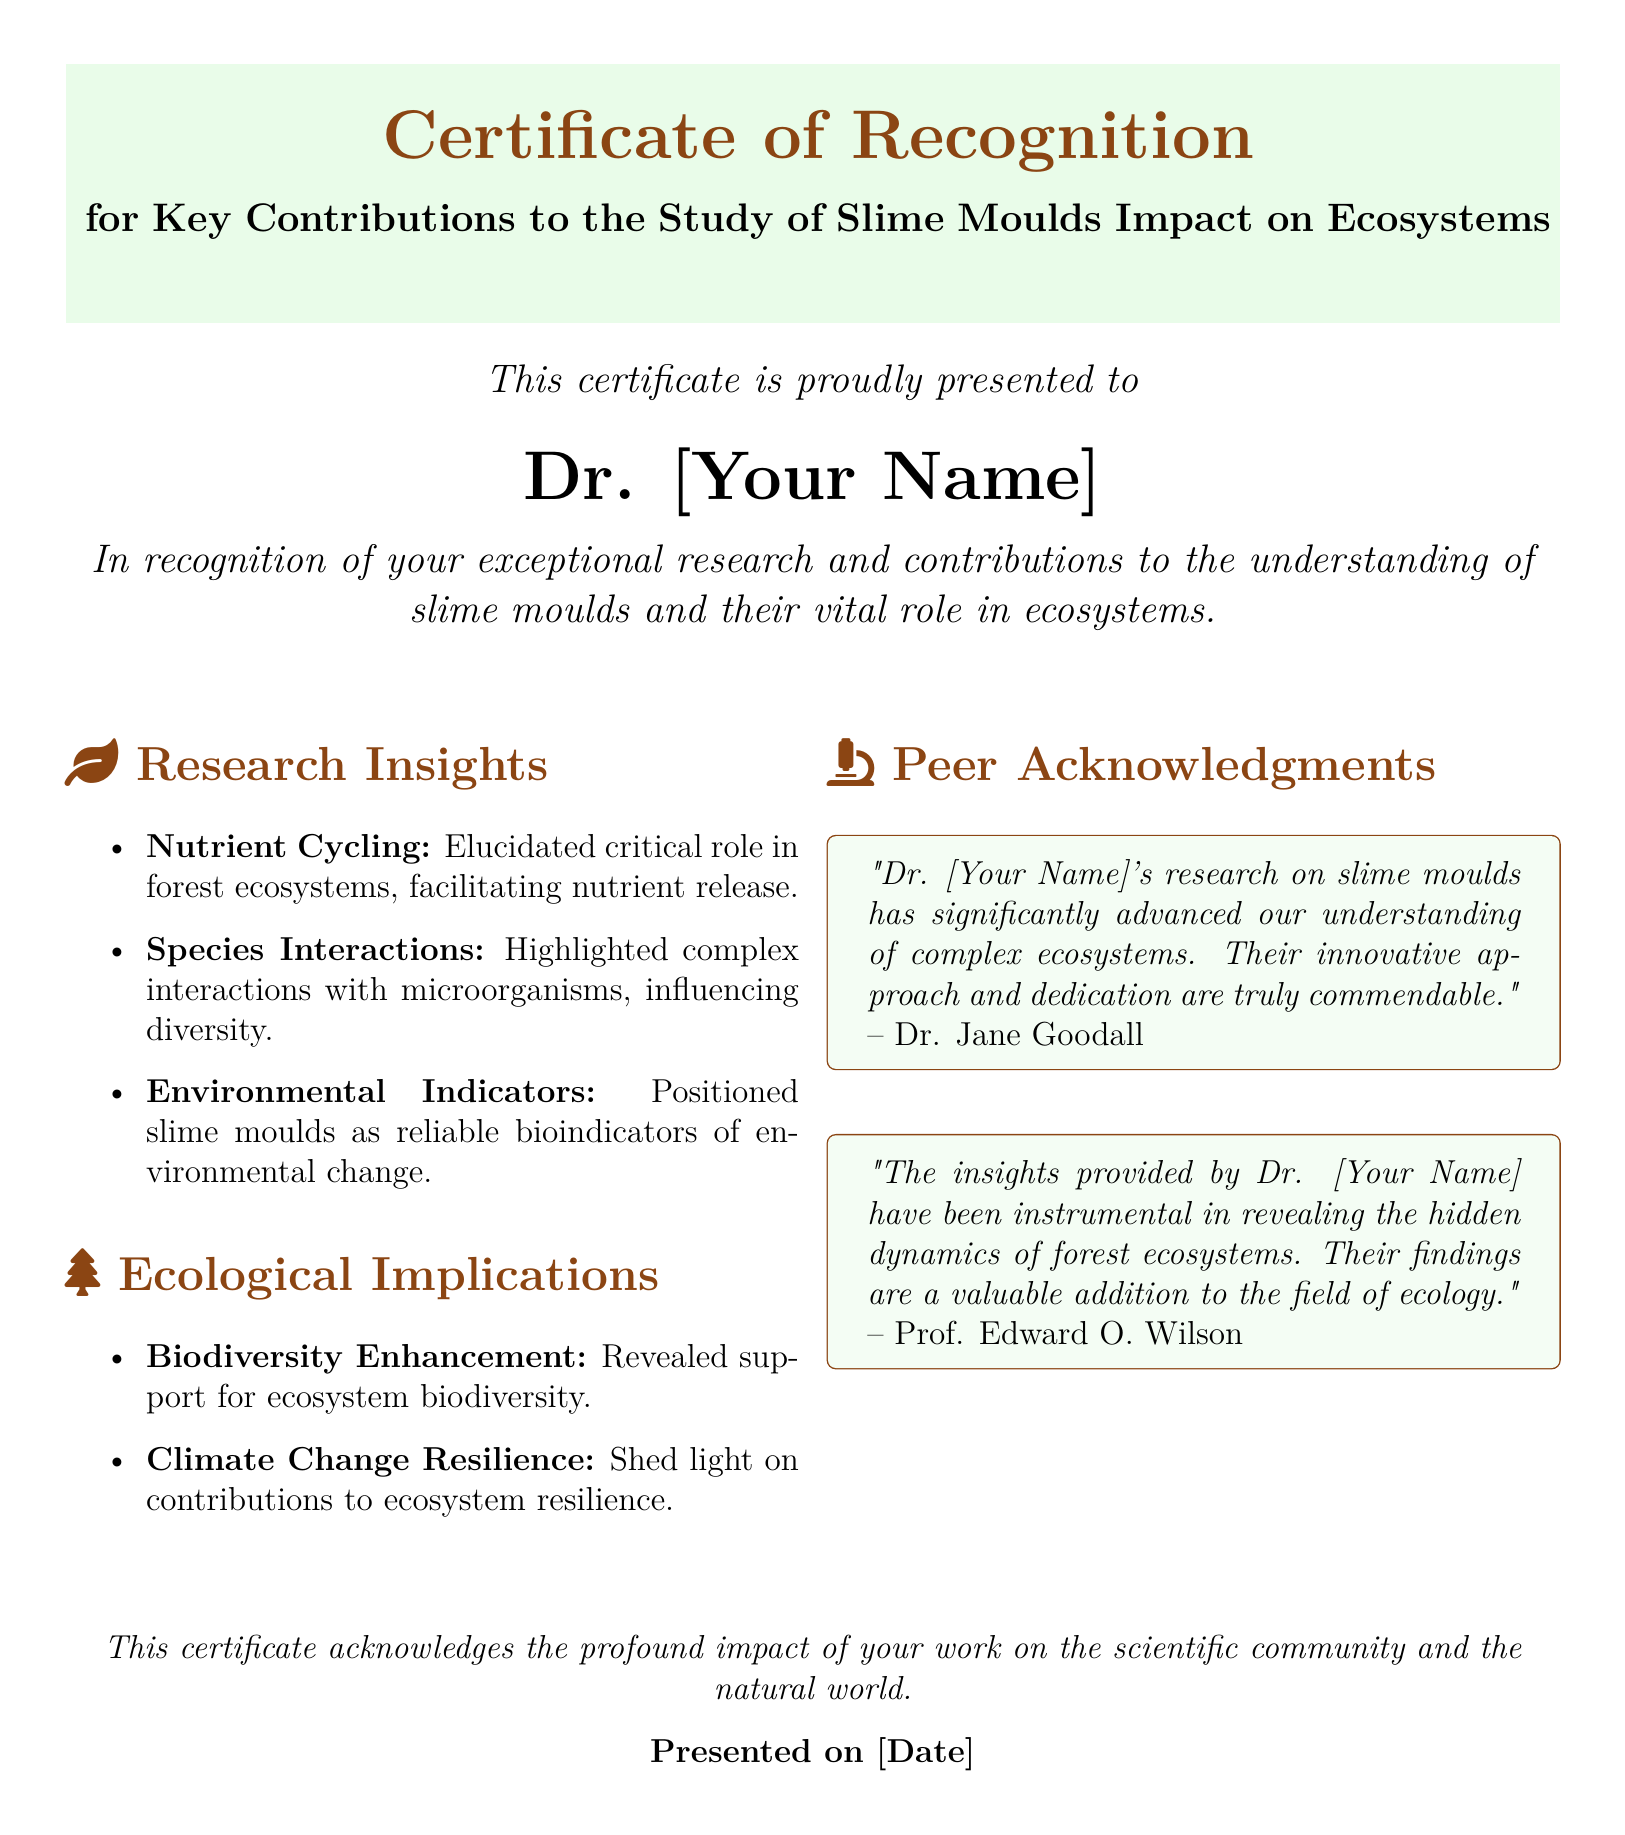What is the title of the certificate? The title of the certificate is presented prominently at the top of the document, highlighting the recognition given.
Answer: Certificate of Recognition for Key Contributions to the Study of Slime Moulds Impact on Ecosystems Who is the certificate presented to? The name of the recipient is clearly stated in the document, acknowledging their contributions.
Answer: Dr. [Your Name] What does the first bullet point under Research Insights mention? The first bullet point specifies a key area of research related to the role of slime moulds in ecosystems.
Answer: Nutrient Cycling What date is this certificate presented on? The presentation date is included at the bottom section of the document.
Answer: [Date] Who acknowledged Dr. [Your Name]'s research stating its significant advancement? A specific acknowledgment in the document attributes praise to an individual for their recognition of Dr. [Your Name]'s research.
Answer: Dr. Jane Goodall What ecological implication is highlighted concerning climate change? This bullet points directly relates the findings to a broader environmental concern discussed in the document.
Answer: Climate Change Resilience What does the second bullet point under Ecological Implications refer to? The bullet point addresses one of the key findings related to ecosystem health in the document.
Answer: Biodiversity Enhancement What format is used for peer acknowledgments? The peer acknowledgment section employs a specific formatting style to highlight quotes relating to the recipient’s research.
Answer: tcolorbox Which organization does the peer acknowledgment quote from Prof. Edward O. Wilson emphasize? The acknowledgment reflects on the dynamics of a specific type of ecosystem, which is noted in the quote.
Answer: forest ecosystems 